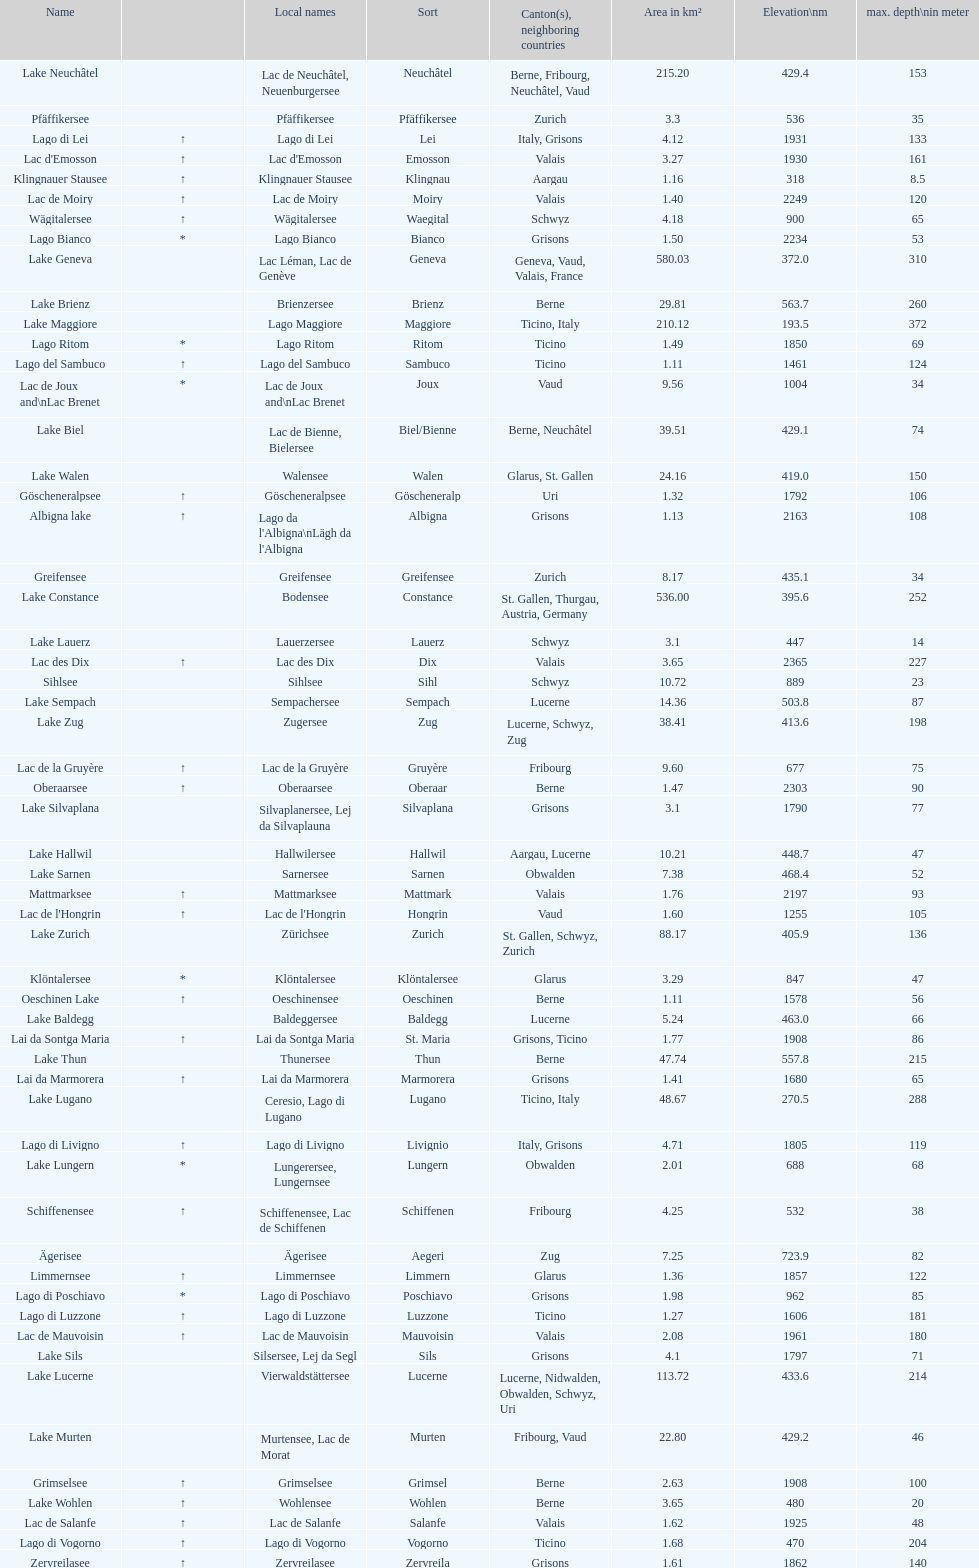What is the deepest lake? Lake Maggiore. 